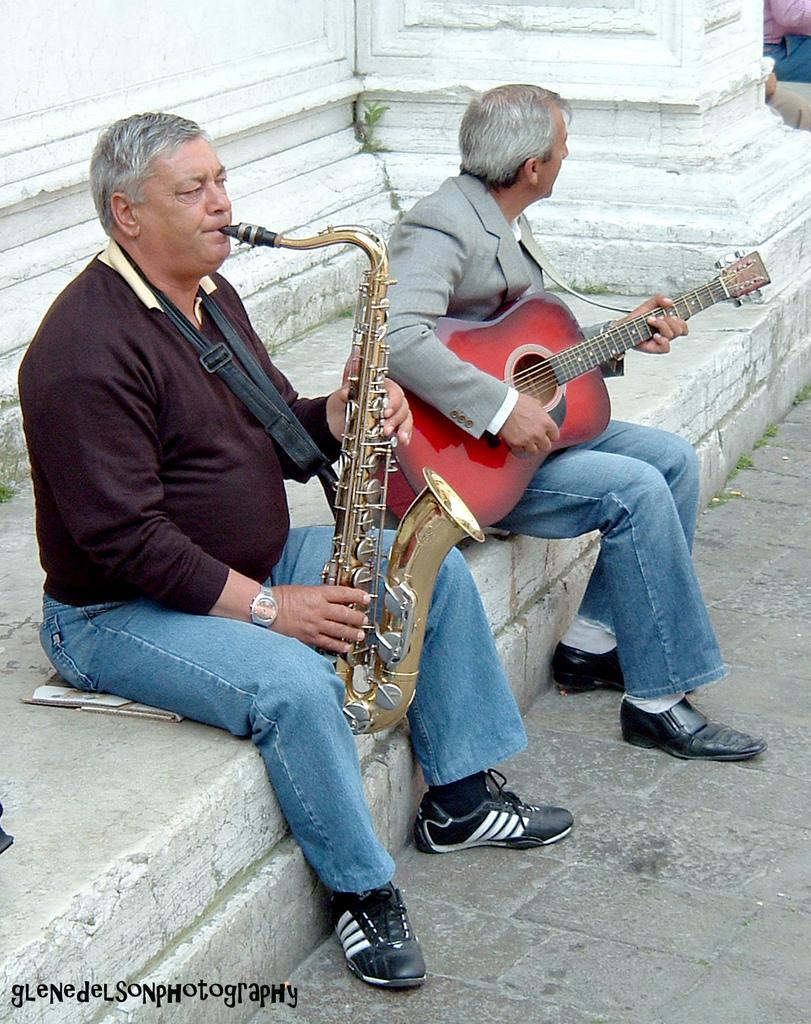How many people are in the image? There are two persons in the image. What are the persons doing in the image? The persons are sitting on the floor and playing musical instruments. What can be seen in the background of the image? There is a white color wall in the background of the image. Can you see any islands or seashore in the image? No, there are no islands or seashore visible in the image. What type of haircut does the person on the left have in the image? There is no information about the person's haircut in the image. 